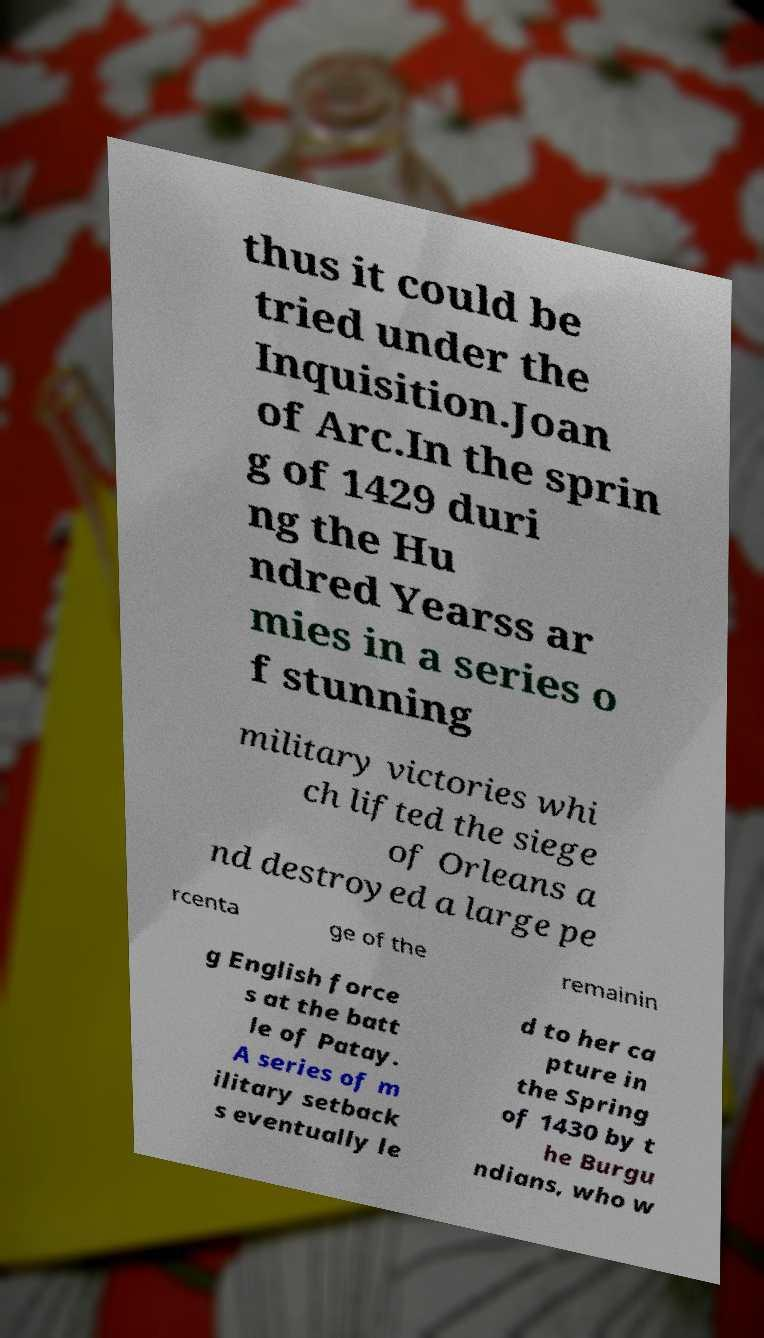Could you extract and type out the text from this image? thus it could be tried under the Inquisition.Joan of Arc.In the sprin g of 1429 duri ng the Hu ndred Yearss ar mies in a series o f stunning military victories whi ch lifted the siege of Orleans a nd destroyed a large pe rcenta ge of the remainin g English force s at the batt le of Patay. A series of m ilitary setback s eventually le d to her ca pture in the Spring of 1430 by t he Burgu ndians, who w 